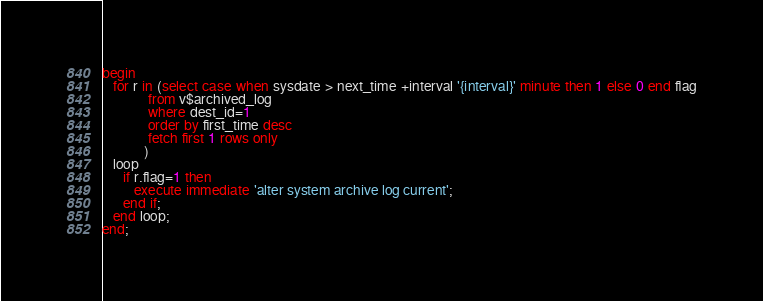<code> <loc_0><loc_0><loc_500><loc_500><_SQL_>begin
   for r in (select case when sysdate > next_time +interval '{interval}' minute then 1 else 0 end flag
             from v$archived_log 
             where dest_id=1
             order by first_time desc
             fetch first 1 rows only
            ) 
   loop
      if r.flag=1 then
         execute immediate 'alter system archive log current';
      end if;
   end loop;
end;
</code> 